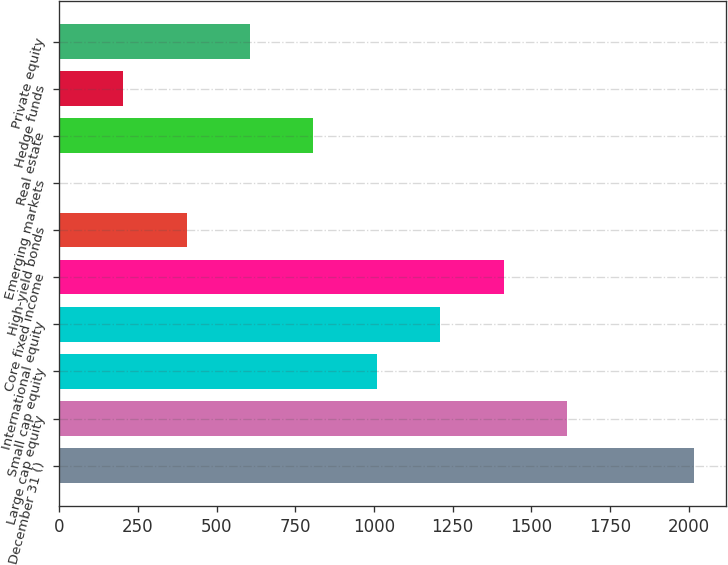Convert chart. <chart><loc_0><loc_0><loc_500><loc_500><bar_chart><fcel>December 31 ()<fcel>Large cap equity<fcel>Small cap equity<fcel>International equity<fcel>Core fixed income<fcel>High-yield bonds<fcel>Emerging markets<fcel>Real estate<fcel>Hedge funds<fcel>Private equity<nl><fcel>2016<fcel>1613.2<fcel>1009<fcel>1210.4<fcel>1411.8<fcel>404.8<fcel>2<fcel>807.6<fcel>203.4<fcel>606.2<nl></chart> 